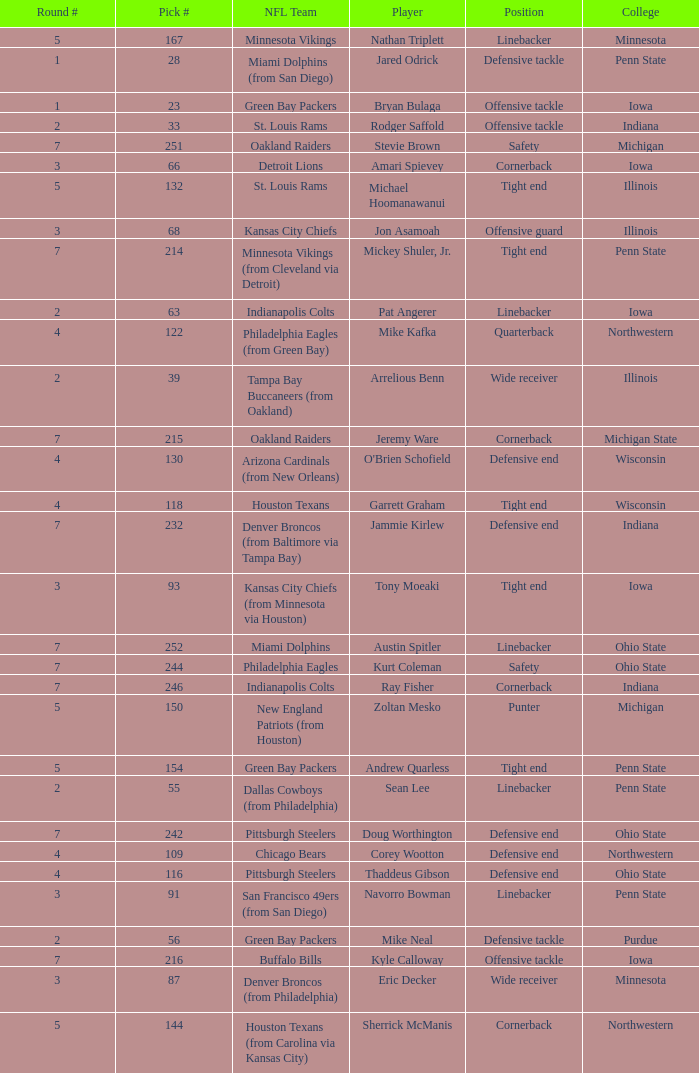I'm looking to parse the entire table for insights. Could you assist me with that? {'header': ['Round #', 'Pick #', 'NFL Team', 'Player', 'Position', 'College'], 'rows': [['5', '167', 'Minnesota Vikings', 'Nathan Triplett', 'Linebacker', 'Minnesota'], ['1', '28', 'Miami Dolphins (from San Diego)', 'Jared Odrick', 'Defensive tackle', 'Penn State'], ['1', '23', 'Green Bay Packers', 'Bryan Bulaga', 'Offensive tackle', 'Iowa'], ['2', '33', 'St. Louis Rams', 'Rodger Saffold', 'Offensive tackle', 'Indiana'], ['7', '251', 'Oakland Raiders', 'Stevie Brown', 'Safety', 'Michigan'], ['3', '66', 'Detroit Lions', 'Amari Spievey', 'Cornerback', 'Iowa'], ['5', '132', 'St. Louis Rams', 'Michael Hoomanawanui', 'Tight end', 'Illinois'], ['3', '68', 'Kansas City Chiefs', 'Jon Asamoah', 'Offensive guard', 'Illinois'], ['7', '214', 'Minnesota Vikings (from Cleveland via Detroit)', 'Mickey Shuler, Jr.', 'Tight end', 'Penn State'], ['2', '63', 'Indianapolis Colts', 'Pat Angerer', 'Linebacker', 'Iowa'], ['4', '122', 'Philadelphia Eagles (from Green Bay)', 'Mike Kafka', 'Quarterback', 'Northwestern'], ['2', '39', 'Tampa Bay Buccaneers (from Oakland)', 'Arrelious Benn', 'Wide receiver', 'Illinois'], ['7', '215', 'Oakland Raiders', 'Jeremy Ware', 'Cornerback', 'Michigan State'], ['4', '130', 'Arizona Cardinals (from New Orleans)', "O'Brien Schofield", 'Defensive end', 'Wisconsin'], ['4', '118', 'Houston Texans', 'Garrett Graham', 'Tight end', 'Wisconsin'], ['7', '232', 'Denver Broncos (from Baltimore via Tampa Bay)', 'Jammie Kirlew', 'Defensive end', 'Indiana'], ['3', '93', 'Kansas City Chiefs (from Minnesota via Houston)', 'Tony Moeaki', 'Tight end', 'Iowa'], ['7', '252', 'Miami Dolphins', 'Austin Spitler', 'Linebacker', 'Ohio State'], ['7', '244', 'Philadelphia Eagles', 'Kurt Coleman', 'Safety', 'Ohio State'], ['7', '246', 'Indianapolis Colts', 'Ray Fisher', 'Cornerback', 'Indiana'], ['5', '150', 'New England Patriots (from Houston)', 'Zoltan Mesko', 'Punter', 'Michigan'], ['5', '154', 'Green Bay Packers', 'Andrew Quarless', 'Tight end', 'Penn State'], ['2', '55', 'Dallas Cowboys (from Philadelphia)', 'Sean Lee', 'Linebacker', 'Penn State'], ['7', '242', 'Pittsburgh Steelers', 'Doug Worthington', 'Defensive end', 'Ohio State'], ['4', '109', 'Chicago Bears', 'Corey Wootton', 'Defensive end', 'Northwestern'], ['4', '116', 'Pittsburgh Steelers', 'Thaddeus Gibson', 'Defensive end', 'Ohio State'], ['3', '91', 'San Francisco 49ers (from San Diego)', 'Navorro Bowman', 'Linebacker', 'Penn State'], ['2', '56', 'Green Bay Packers', 'Mike Neal', 'Defensive tackle', 'Purdue'], ['7', '216', 'Buffalo Bills', 'Kyle Calloway', 'Offensive tackle', 'Iowa'], ['3', '87', 'Denver Broncos (from Philadelphia)', 'Eric Decker', 'Wide receiver', 'Minnesota'], ['5', '144', 'Houston Texans (from Carolina via Kansas City)', 'Sherrick McManis', 'Cornerback', 'Northwestern']]} What NFL team was the player with pick number 28 drafted to? Miami Dolphins (from San Diego). 